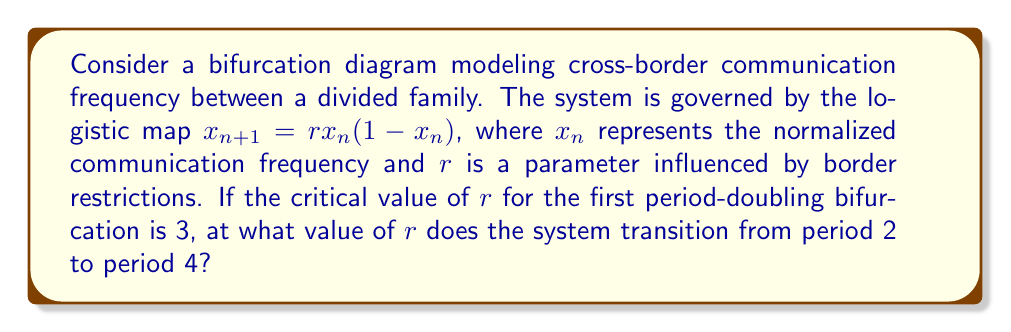Solve this math problem. To solve this problem, we need to understand the period-doubling cascade in the logistic map:

1) The first period-doubling bifurcation occurs at $r_1 = 3$.

2) Subsequent bifurcations occur at decreasing intervals, following a geometric sequence with a ratio known as the Feigenbaum constant, $\delta \approx 4.669201609...$.

3) Let $r_2$ be the value we're looking for (transition from period 2 to 4). The Feigenbaum constant relates consecutive bifurcation points:

   $$\delta = \lim_{n \to \infty} \frac{r_n - r_{n-1}}{r_{n+1} - r_n}$$

4) For the first few bifurcations, this ratio is approximately constant:

   $$\delta \approx \frac{r_2 - r_1}{r_3 - r_2} \approx \frac{r_1 - r_0}{r_2 - r_1}$$

5) We know $r_1 = 3$ and $r_0 = 1$ (the point where oscillations begin). Substituting:

   $$\frac{3 - 1}{r_2 - 3} \approx 4.669201609$$

6) Solving for $r_2$:

   $$r_2 \approx 3 + \frac{2}{4.669201609} \approx 3.4494897$$

Therefore, the system transitions from period 2 to period 4 at approximately $r = 3.4494897$.
Answer: $r \approx 3.4494897$ 